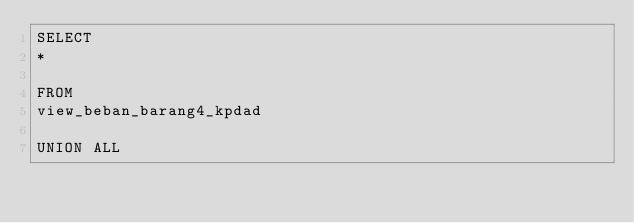Convert code to text. <code><loc_0><loc_0><loc_500><loc_500><_SQL_>SELECT
*

FROM
view_beban_barang4_kpdad

UNION ALL
</code> 